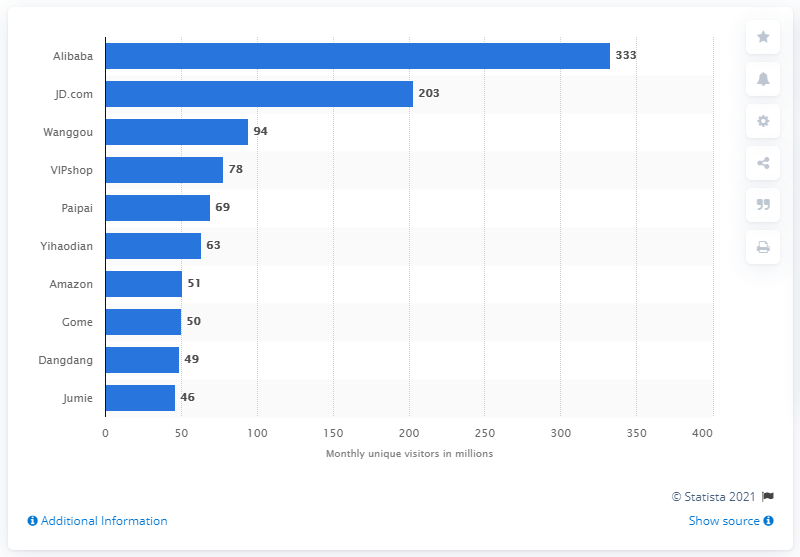Draw attention to some important aspects in this diagram. Alibaba receives approximately 333 unique visitors monthly. 